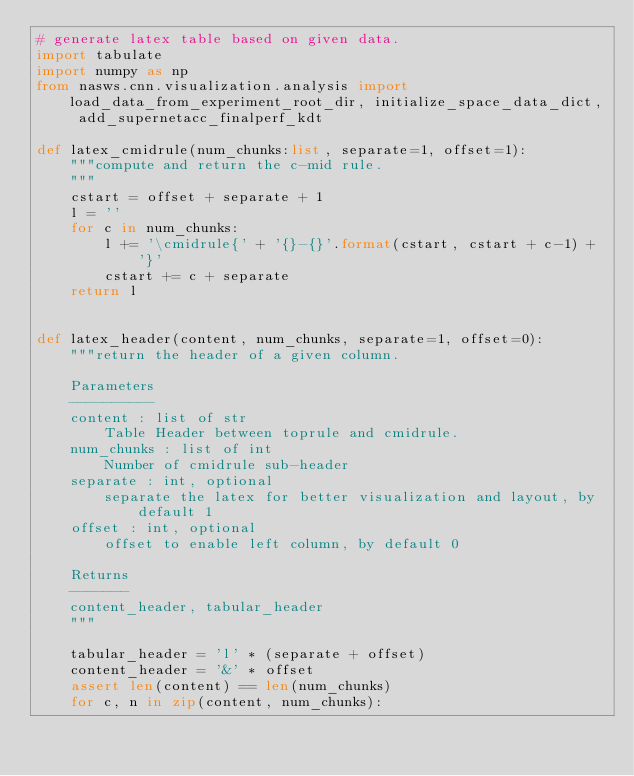Convert code to text. <code><loc_0><loc_0><loc_500><loc_500><_Python_># generate latex table based on given data.
import tabulate 
import numpy as np
from nasws.cnn.visualization.analysis import load_data_from_experiment_root_dir, initialize_space_data_dict, add_supernetacc_finalperf_kdt

def latex_cmidrule(num_chunks:list, separate=1, offset=1):
    """compute and return the c-mid rule.
    """
    cstart = offset + separate + 1
    l = ''
    for c in num_chunks:
        l += '\cmidrule{' + '{}-{}'.format(cstart, cstart + c-1) + '}'
        cstart += c + separate
    return l


def latex_header(content, num_chunks, separate=1, offset=0):
    """return the header of a given column.
    
    Parameters
    ----------
    content : list of str
        Table Header between toprule and cmidrule.
    num_chunks : list of int
        Number of cmidrule sub-header
    separate : int, optional
        separate the latex for better visualization and layout, by default 1
    offset : int, optional
        offset to enable left column, by default 0

    Returns
    -------
    content_header, tabular_header
    """
    
    tabular_header = 'l' * (separate + offset)
    content_header = '&' * offset 
    assert len(content) == len(num_chunks)
    for c, n in zip(content, num_chunks):</code> 